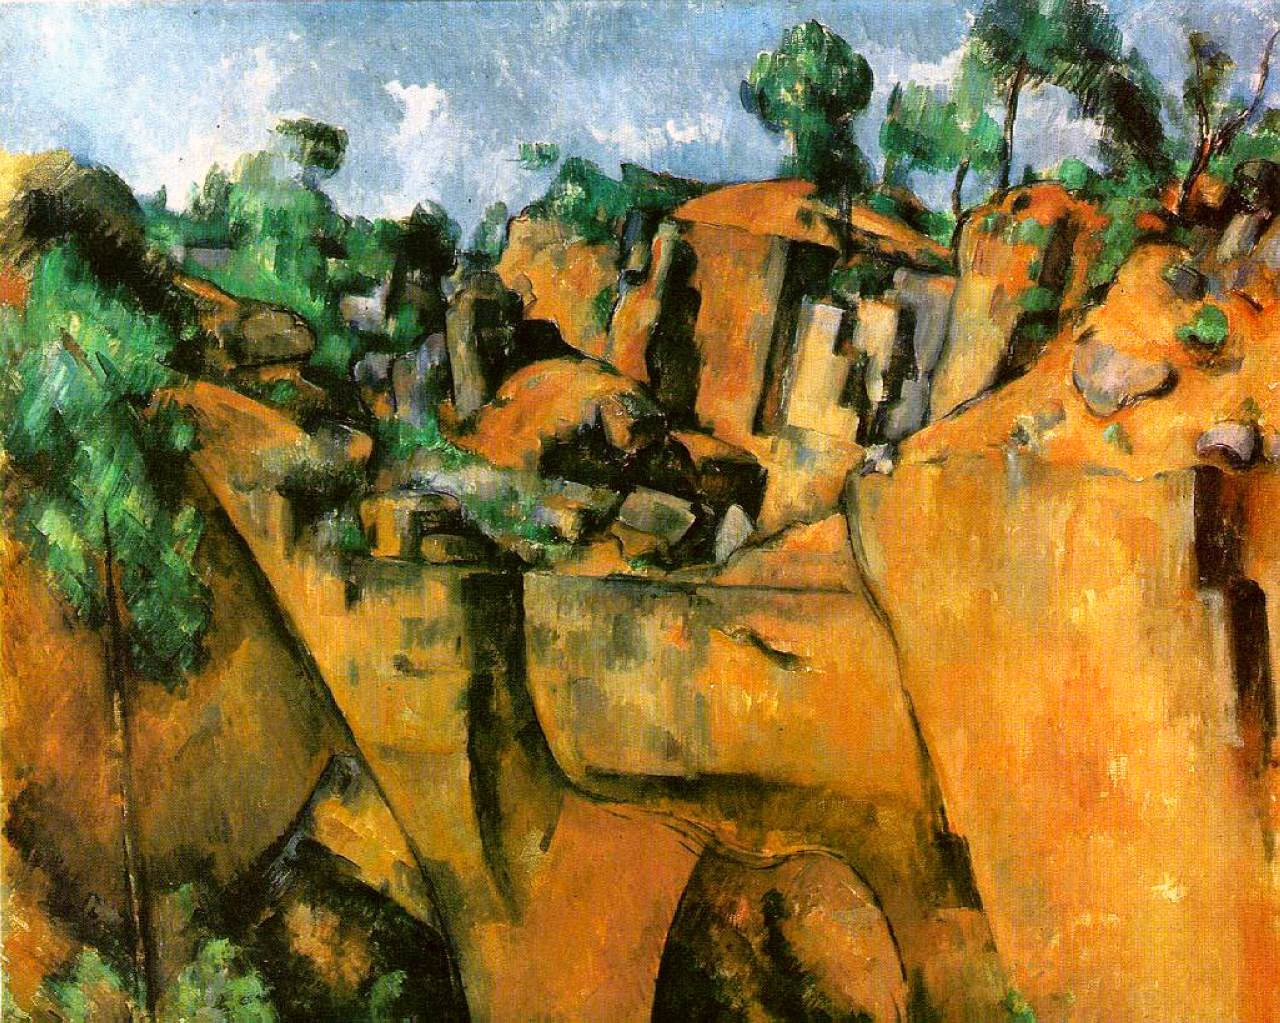Can you comment on the emotional impact this painting might have on a viewer? The painting's vibrant colors combined with the rough texture imparted by the pronounced brushstrokes may evoke a range of emotions, from tranquility and awe to a stirring of adventure due to the rugged terrain. The interplay of natural forms and human structures might also reflect themes of resilience or harmony between humans and nature, provoking contemplation or emotional connection with the environment. What does the choice of colors tell us about the painting? The choice of earthy tones like browns and greens anchored by vibrant oranges suggests a scene rich with life and vitality yet grounded in the stable, enduring essence of nature. These colors could be suggesting the time of harvest or the transition between seasons, possibly imbuing the painting with a sense of change or time passing. 